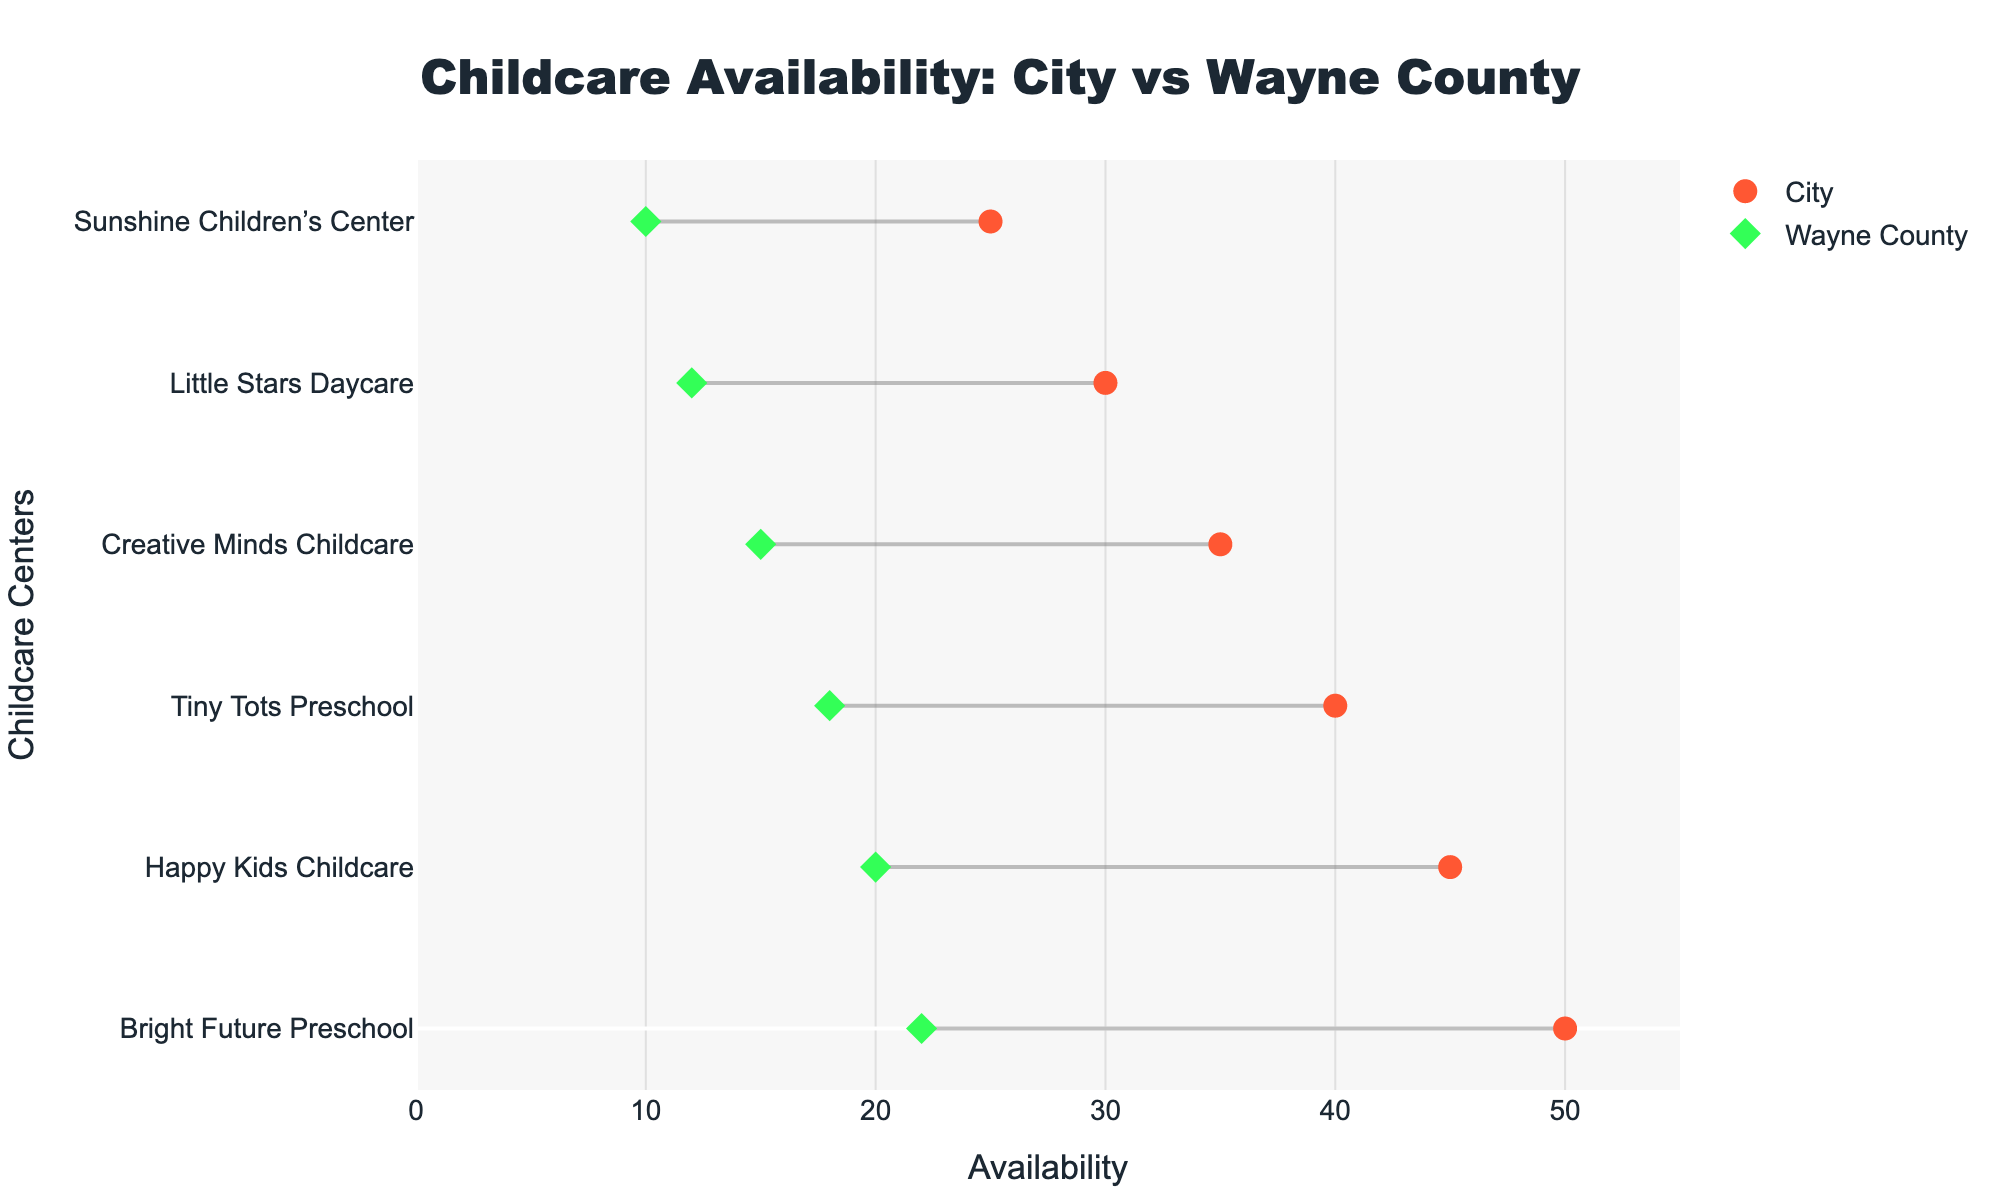What is the title of the figure? The title of the figure is prominently displayed at the top of the plot.
Answer: "Childcare Availability: City vs Wayne County" How many childcare centers are listed for the city? By counting the markers and ticks associated with the city, we see there are 6 centers listed.
Answer: 6 How many childcare centers are listed for Wayne County? By counting the markers and ticks associated with Wayne County, we see there are 6 centers listed.
Answer: 6 Which childcare center in Wayne County has the highest availability? By examining the markers for Wayne County, the center with the highest value on the x-axis represents the highest availability, which is Discovery Kids Center with an availability of 22.
Answer: "Discovery Kids Center" Which childcare center in the city has the highest quality rating and how much is it? By examining the hover text of city markers, Little Stars Daycare has the highest quality rating at 4.5.
Answer: "Little Stars Daycare, 4.5" What is the combined availability of all the childcare centers in Wayne County? Sum the availability values for all Wayne County centers: 20 + 15 + 18 + 22 + 10 + 12 = 97.
Answer: 97 How does the average quality rating in the city compare to that in Wayne County? Calculate the average quality rating for both the city and Wayne County. City: (4.2 + 4.5 + 3.9 + 4.0 + 4.1 + 3.8) / 6 = 24.5 / 6 = 4.083. Wayne County: (4.5 + 4.7 + 4.6 + 4.4 + 4.3 + 4.0) / 6 = 26.5 / 6 = 4.417. Compare 4.083 to 4.417.
Answer: Wayne County has a higher average quality rating What is the difference in availability between the childcare center with the highest and the lowest ratings in Wayne County? Identify the highest-rated (Little Explorers Childcare, 15) and lowest-rated (Little Buddies Childcare, 12) centers in Wayne County. Calculate the difference: 15 - 12 = 3.
Answer: 3 Are there any childcare centers in the city with a quality rating below 4.0? Examining the hover text of city markers, Bright Future Preschool (3.9) and Sunshine Children’s Center (3.8) have ratings below 4.0.
Answer: Yes Which side (City or Wayne County) has more variability in availability among childcare centers? Compare the range of availability values for both locations. City (50 - 25 = 25), Wayne County (22 - 10 = 12).
Answer: City 